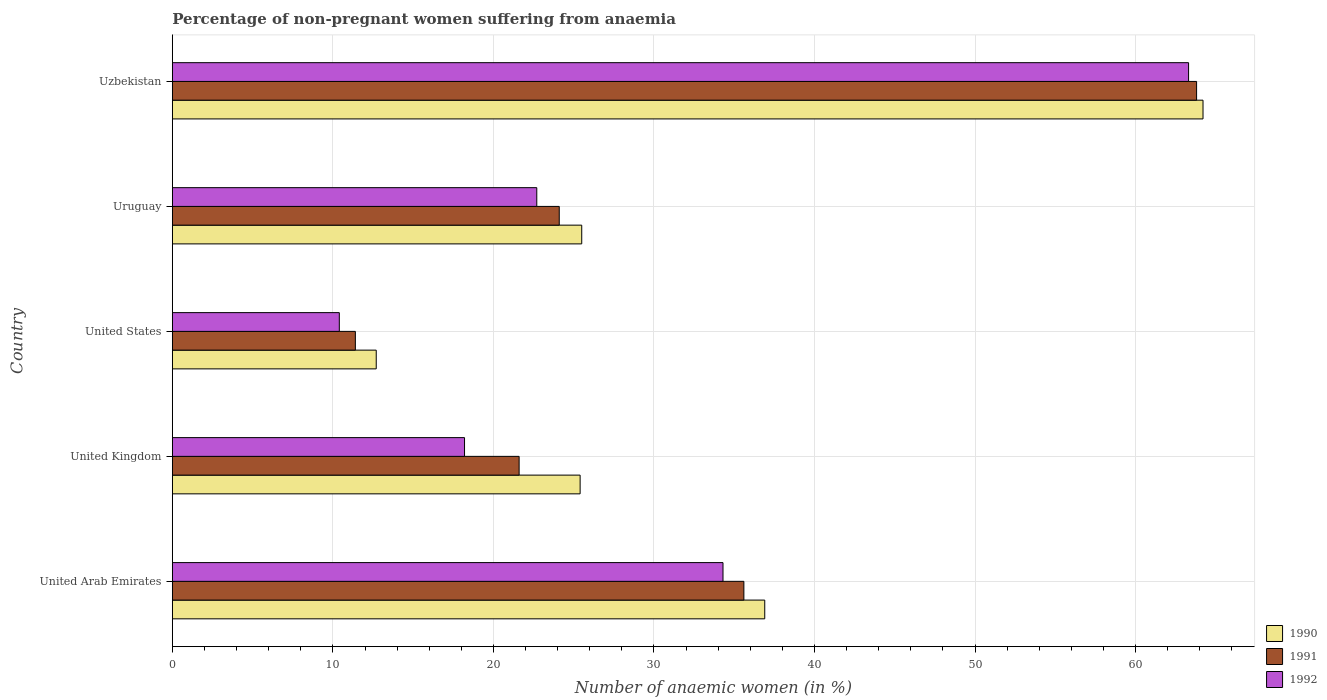How many different coloured bars are there?
Give a very brief answer. 3. Are the number of bars on each tick of the Y-axis equal?
Offer a very short reply. Yes. How many bars are there on the 5th tick from the bottom?
Provide a short and direct response. 3. What is the label of the 5th group of bars from the top?
Your response must be concise. United Arab Emirates. What is the percentage of non-pregnant women suffering from anaemia in 1991 in United Arab Emirates?
Offer a terse response. 35.6. Across all countries, what is the maximum percentage of non-pregnant women suffering from anaemia in 1991?
Your answer should be compact. 63.8. Across all countries, what is the minimum percentage of non-pregnant women suffering from anaemia in 1990?
Provide a short and direct response. 12.7. In which country was the percentage of non-pregnant women suffering from anaemia in 1990 maximum?
Provide a succinct answer. Uzbekistan. In which country was the percentage of non-pregnant women suffering from anaemia in 1990 minimum?
Provide a succinct answer. United States. What is the total percentage of non-pregnant women suffering from anaemia in 1991 in the graph?
Provide a succinct answer. 156.5. What is the difference between the percentage of non-pregnant women suffering from anaemia in 1992 in United Kingdom and that in United States?
Your answer should be very brief. 7.8. What is the difference between the percentage of non-pregnant women suffering from anaemia in 1990 in United Kingdom and the percentage of non-pregnant women suffering from anaemia in 1991 in Uzbekistan?
Provide a short and direct response. -38.4. What is the average percentage of non-pregnant women suffering from anaemia in 1992 per country?
Offer a very short reply. 29.78. What is the difference between the percentage of non-pregnant women suffering from anaemia in 1991 and percentage of non-pregnant women suffering from anaemia in 1992 in Uruguay?
Ensure brevity in your answer.  1.4. What is the ratio of the percentage of non-pregnant women suffering from anaemia in 1992 in United Arab Emirates to that in Uzbekistan?
Offer a very short reply. 0.54. Is the percentage of non-pregnant women suffering from anaemia in 1990 in United Kingdom less than that in Uzbekistan?
Give a very brief answer. Yes. Is the difference between the percentage of non-pregnant women suffering from anaemia in 1991 in Uruguay and Uzbekistan greater than the difference between the percentage of non-pregnant women suffering from anaemia in 1992 in Uruguay and Uzbekistan?
Ensure brevity in your answer.  Yes. What is the difference between the highest and the second highest percentage of non-pregnant women suffering from anaemia in 1990?
Provide a succinct answer. 27.3. What is the difference between the highest and the lowest percentage of non-pregnant women suffering from anaemia in 1991?
Make the answer very short. 52.4. In how many countries, is the percentage of non-pregnant women suffering from anaemia in 1991 greater than the average percentage of non-pregnant women suffering from anaemia in 1991 taken over all countries?
Your answer should be compact. 2. Is the sum of the percentage of non-pregnant women suffering from anaemia in 1991 in United Kingdom and United States greater than the maximum percentage of non-pregnant women suffering from anaemia in 1992 across all countries?
Offer a very short reply. No. What does the 2nd bar from the bottom in United States represents?
Make the answer very short. 1991. Is it the case that in every country, the sum of the percentage of non-pregnant women suffering from anaemia in 1990 and percentage of non-pregnant women suffering from anaemia in 1991 is greater than the percentage of non-pregnant women suffering from anaemia in 1992?
Give a very brief answer. Yes. How many bars are there?
Your answer should be very brief. 15. Are all the bars in the graph horizontal?
Provide a short and direct response. Yes. How many countries are there in the graph?
Your response must be concise. 5. What is the difference between two consecutive major ticks on the X-axis?
Offer a very short reply. 10. Where does the legend appear in the graph?
Ensure brevity in your answer.  Bottom right. How are the legend labels stacked?
Offer a very short reply. Vertical. What is the title of the graph?
Make the answer very short. Percentage of non-pregnant women suffering from anaemia. Does "2002" appear as one of the legend labels in the graph?
Ensure brevity in your answer.  No. What is the label or title of the X-axis?
Your answer should be compact. Number of anaemic women (in %). What is the Number of anaemic women (in %) in 1990 in United Arab Emirates?
Offer a terse response. 36.9. What is the Number of anaemic women (in %) in 1991 in United Arab Emirates?
Your answer should be compact. 35.6. What is the Number of anaemic women (in %) in 1992 in United Arab Emirates?
Provide a succinct answer. 34.3. What is the Number of anaemic women (in %) in 1990 in United Kingdom?
Offer a terse response. 25.4. What is the Number of anaemic women (in %) of 1991 in United Kingdom?
Offer a very short reply. 21.6. What is the Number of anaemic women (in %) of 1990 in United States?
Your answer should be very brief. 12.7. What is the Number of anaemic women (in %) in 1991 in United States?
Provide a succinct answer. 11.4. What is the Number of anaemic women (in %) of 1992 in United States?
Your answer should be compact. 10.4. What is the Number of anaemic women (in %) of 1991 in Uruguay?
Ensure brevity in your answer.  24.1. What is the Number of anaemic women (in %) in 1992 in Uruguay?
Ensure brevity in your answer.  22.7. What is the Number of anaemic women (in %) of 1990 in Uzbekistan?
Keep it short and to the point. 64.2. What is the Number of anaemic women (in %) in 1991 in Uzbekistan?
Your answer should be very brief. 63.8. What is the Number of anaemic women (in %) of 1992 in Uzbekistan?
Keep it short and to the point. 63.3. Across all countries, what is the maximum Number of anaemic women (in %) in 1990?
Offer a terse response. 64.2. Across all countries, what is the maximum Number of anaemic women (in %) in 1991?
Your answer should be compact. 63.8. Across all countries, what is the maximum Number of anaemic women (in %) of 1992?
Give a very brief answer. 63.3. Across all countries, what is the minimum Number of anaemic women (in %) of 1990?
Offer a terse response. 12.7. Across all countries, what is the minimum Number of anaemic women (in %) of 1992?
Your response must be concise. 10.4. What is the total Number of anaemic women (in %) of 1990 in the graph?
Offer a very short reply. 164.7. What is the total Number of anaemic women (in %) of 1991 in the graph?
Provide a succinct answer. 156.5. What is the total Number of anaemic women (in %) of 1992 in the graph?
Provide a short and direct response. 148.9. What is the difference between the Number of anaemic women (in %) of 1991 in United Arab Emirates and that in United Kingdom?
Ensure brevity in your answer.  14. What is the difference between the Number of anaemic women (in %) in 1992 in United Arab Emirates and that in United Kingdom?
Ensure brevity in your answer.  16.1. What is the difference between the Number of anaemic women (in %) of 1990 in United Arab Emirates and that in United States?
Ensure brevity in your answer.  24.2. What is the difference between the Number of anaemic women (in %) of 1991 in United Arab Emirates and that in United States?
Give a very brief answer. 24.2. What is the difference between the Number of anaemic women (in %) of 1992 in United Arab Emirates and that in United States?
Your answer should be very brief. 23.9. What is the difference between the Number of anaemic women (in %) of 1991 in United Arab Emirates and that in Uruguay?
Your answer should be very brief. 11.5. What is the difference between the Number of anaemic women (in %) of 1992 in United Arab Emirates and that in Uruguay?
Ensure brevity in your answer.  11.6. What is the difference between the Number of anaemic women (in %) of 1990 in United Arab Emirates and that in Uzbekistan?
Offer a very short reply. -27.3. What is the difference between the Number of anaemic women (in %) in 1991 in United Arab Emirates and that in Uzbekistan?
Make the answer very short. -28.2. What is the difference between the Number of anaemic women (in %) in 1992 in United Arab Emirates and that in Uzbekistan?
Your response must be concise. -29. What is the difference between the Number of anaemic women (in %) of 1990 in United Kingdom and that in United States?
Your answer should be very brief. 12.7. What is the difference between the Number of anaemic women (in %) in 1990 in United Kingdom and that in Uruguay?
Provide a succinct answer. -0.1. What is the difference between the Number of anaemic women (in %) of 1991 in United Kingdom and that in Uruguay?
Provide a short and direct response. -2.5. What is the difference between the Number of anaemic women (in %) of 1992 in United Kingdom and that in Uruguay?
Offer a terse response. -4.5. What is the difference between the Number of anaemic women (in %) in 1990 in United Kingdom and that in Uzbekistan?
Ensure brevity in your answer.  -38.8. What is the difference between the Number of anaemic women (in %) of 1991 in United Kingdom and that in Uzbekistan?
Provide a short and direct response. -42.2. What is the difference between the Number of anaemic women (in %) in 1992 in United Kingdom and that in Uzbekistan?
Ensure brevity in your answer.  -45.1. What is the difference between the Number of anaemic women (in %) in 1991 in United States and that in Uruguay?
Make the answer very short. -12.7. What is the difference between the Number of anaemic women (in %) in 1992 in United States and that in Uruguay?
Offer a terse response. -12.3. What is the difference between the Number of anaemic women (in %) in 1990 in United States and that in Uzbekistan?
Make the answer very short. -51.5. What is the difference between the Number of anaemic women (in %) of 1991 in United States and that in Uzbekistan?
Ensure brevity in your answer.  -52.4. What is the difference between the Number of anaemic women (in %) in 1992 in United States and that in Uzbekistan?
Your answer should be very brief. -52.9. What is the difference between the Number of anaemic women (in %) of 1990 in Uruguay and that in Uzbekistan?
Your response must be concise. -38.7. What is the difference between the Number of anaemic women (in %) in 1991 in Uruguay and that in Uzbekistan?
Your answer should be very brief. -39.7. What is the difference between the Number of anaemic women (in %) of 1992 in Uruguay and that in Uzbekistan?
Your answer should be very brief. -40.6. What is the difference between the Number of anaemic women (in %) in 1990 in United Arab Emirates and the Number of anaemic women (in %) in 1992 in United Kingdom?
Offer a terse response. 18.7. What is the difference between the Number of anaemic women (in %) in 1991 in United Arab Emirates and the Number of anaemic women (in %) in 1992 in United Kingdom?
Your answer should be compact. 17.4. What is the difference between the Number of anaemic women (in %) in 1990 in United Arab Emirates and the Number of anaemic women (in %) in 1991 in United States?
Give a very brief answer. 25.5. What is the difference between the Number of anaemic women (in %) of 1990 in United Arab Emirates and the Number of anaemic women (in %) of 1992 in United States?
Ensure brevity in your answer.  26.5. What is the difference between the Number of anaemic women (in %) in 1991 in United Arab Emirates and the Number of anaemic women (in %) in 1992 in United States?
Make the answer very short. 25.2. What is the difference between the Number of anaemic women (in %) of 1990 in United Arab Emirates and the Number of anaemic women (in %) of 1992 in Uruguay?
Your response must be concise. 14.2. What is the difference between the Number of anaemic women (in %) in 1990 in United Arab Emirates and the Number of anaemic women (in %) in 1991 in Uzbekistan?
Your answer should be compact. -26.9. What is the difference between the Number of anaemic women (in %) in 1990 in United Arab Emirates and the Number of anaemic women (in %) in 1992 in Uzbekistan?
Keep it short and to the point. -26.4. What is the difference between the Number of anaemic women (in %) of 1991 in United Arab Emirates and the Number of anaemic women (in %) of 1992 in Uzbekistan?
Keep it short and to the point. -27.7. What is the difference between the Number of anaemic women (in %) of 1990 in United Kingdom and the Number of anaemic women (in %) of 1992 in United States?
Your response must be concise. 15. What is the difference between the Number of anaemic women (in %) of 1991 in United Kingdom and the Number of anaemic women (in %) of 1992 in United States?
Provide a succinct answer. 11.2. What is the difference between the Number of anaemic women (in %) of 1991 in United Kingdom and the Number of anaemic women (in %) of 1992 in Uruguay?
Your response must be concise. -1.1. What is the difference between the Number of anaemic women (in %) of 1990 in United Kingdom and the Number of anaemic women (in %) of 1991 in Uzbekistan?
Your answer should be very brief. -38.4. What is the difference between the Number of anaemic women (in %) in 1990 in United Kingdom and the Number of anaemic women (in %) in 1992 in Uzbekistan?
Offer a terse response. -37.9. What is the difference between the Number of anaemic women (in %) in 1991 in United Kingdom and the Number of anaemic women (in %) in 1992 in Uzbekistan?
Ensure brevity in your answer.  -41.7. What is the difference between the Number of anaemic women (in %) of 1990 in United States and the Number of anaemic women (in %) of 1991 in Uruguay?
Make the answer very short. -11.4. What is the difference between the Number of anaemic women (in %) in 1990 in United States and the Number of anaemic women (in %) in 1992 in Uruguay?
Ensure brevity in your answer.  -10. What is the difference between the Number of anaemic women (in %) of 1990 in United States and the Number of anaemic women (in %) of 1991 in Uzbekistan?
Offer a terse response. -51.1. What is the difference between the Number of anaemic women (in %) in 1990 in United States and the Number of anaemic women (in %) in 1992 in Uzbekistan?
Offer a terse response. -50.6. What is the difference between the Number of anaemic women (in %) in 1991 in United States and the Number of anaemic women (in %) in 1992 in Uzbekistan?
Offer a very short reply. -51.9. What is the difference between the Number of anaemic women (in %) of 1990 in Uruguay and the Number of anaemic women (in %) of 1991 in Uzbekistan?
Provide a short and direct response. -38.3. What is the difference between the Number of anaemic women (in %) of 1990 in Uruguay and the Number of anaemic women (in %) of 1992 in Uzbekistan?
Offer a very short reply. -37.8. What is the difference between the Number of anaemic women (in %) in 1991 in Uruguay and the Number of anaemic women (in %) in 1992 in Uzbekistan?
Make the answer very short. -39.2. What is the average Number of anaemic women (in %) of 1990 per country?
Your response must be concise. 32.94. What is the average Number of anaemic women (in %) of 1991 per country?
Offer a terse response. 31.3. What is the average Number of anaemic women (in %) in 1992 per country?
Your response must be concise. 29.78. What is the difference between the Number of anaemic women (in %) of 1990 and Number of anaemic women (in %) of 1991 in United Arab Emirates?
Offer a very short reply. 1.3. What is the difference between the Number of anaemic women (in %) of 1990 and Number of anaemic women (in %) of 1992 in United Arab Emirates?
Offer a very short reply. 2.6. What is the difference between the Number of anaemic women (in %) in 1991 and Number of anaemic women (in %) in 1992 in United Arab Emirates?
Offer a very short reply. 1.3. What is the difference between the Number of anaemic women (in %) in 1990 and Number of anaemic women (in %) in 1991 in United Kingdom?
Your response must be concise. 3.8. What is the difference between the Number of anaemic women (in %) in 1990 and Number of anaemic women (in %) in 1992 in United Kingdom?
Provide a succinct answer. 7.2. What is the difference between the Number of anaemic women (in %) of 1991 and Number of anaemic women (in %) of 1992 in United Kingdom?
Ensure brevity in your answer.  3.4. What is the difference between the Number of anaemic women (in %) in 1990 and Number of anaemic women (in %) in 1992 in United States?
Your answer should be very brief. 2.3. What is the difference between the Number of anaemic women (in %) in 1991 and Number of anaemic women (in %) in 1992 in United States?
Make the answer very short. 1. What is the difference between the Number of anaemic women (in %) of 1990 and Number of anaemic women (in %) of 1992 in Uruguay?
Offer a very short reply. 2.8. What is the difference between the Number of anaemic women (in %) of 1991 and Number of anaemic women (in %) of 1992 in Uruguay?
Offer a terse response. 1.4. What is the difference between the Number of anaemic women (in %) of 1990 and Number of anaemic women (in %) of 1991 in Uzbekistan?
Your answer should be very brief. 0.4. What is the ratio of the Number of anaemic women (in %) of 1990 in United Arab Emirates to that in United Kingdom?
Offer a terse response. 1.45. What is the ratio of the Number of anaemic women (in %) of 1991 in United Arab Emirates to that in United Kingdom?
Offer a terse response. 1.65. What is the ratio of the Number of anaemic women (in %) in 1992 in United Arab Emirates to that in United Kingdom?
Ensure brevity in your answer.  1.88. What is the ratio of the Number of anaemic women (in %) of 1990 in United Arab Emirates to that in United States?
Your answer should be compact. 2.91. What is the ratio of the Number of anaemic women (in %) in 1991 in United Arab Emirates to that in United States?
Provide a short and direct response. 3.12. What is the ratio of the Number of anaemic women (in %) of 1992 in United Arab Emirates to that in United States?
Keep it short and to the point. 3.3. What is the ratio of the Number of anaemic women (in %) of 1990 in United Arab Emirates to that in Uruguay?
Give a very brief answer. 1.45. What is the ratio of the Number of anaemic women (in %) of 1991 in United Arab Emirates to that in Uruguay?
Your answer should be compact. 1.48. What is the ratio of the Number of anaemic women (in %) of 1992 in United Arab Emirates to that in Uruguay?
Your answer should be compact. 1.51. What is the ratio of the Number of anaemic women (in %) of 1990 in United Arab Emirates to that in Uzbekistan?
Make the answer very short. 0.57. What is the ratio of the Number of anaemic women (in %) in 1991 in United Arab Emirates to that in Uzbekistan?
Offer a very short reply. 0.56. What is the ratio of the Number of anaemic women (in %) of 1992 in United Arab Emirates to that in Uzbekistan?
Provide a short and direct response. 0.54. What is the ratio of the Number of anaemic women (in %) in 1990 in United Kingdom to that in United States?
Your answer should be very brief. 2. What is the ratio of the Number of anaemic women (in %) of 1991 in United Kingdom to that in United States?
Ensure brevity in your answer.  1.89. What is the ratio of the Number of anaemic women (in %) of 1990 in United Kingdom to that in Uruguay?
Offer a very short reply. 1. What is the ratio of the Number of anaemic women (in %) of 1991 in United Kingdom to that in Uruguay?
Your response must be concise. 0.9. What is the ratio of the Number of anaemic women (in %) of 1992 in United Kingdom to that in Uruguay?
Provide a succinct answer. 0.8. What is the ratio of the Number of anaemic women (in %) of 1990 in United Kingdom to that in Uzbekistan?
Keep it short and to the point. 0.4. What is the ratio of the Number of anaemic women (in %) in 1991 in United Kingdom to that in Uzbekistan?
Your answer should be compact. 0.34. What is the ratio of the Number of anaemic women (in %) of 1992 in United Kingdom to that in Uzbekistan?
Your answer should be very brief. 0.29. What is the ratio of the Number of anaemic women (in %) of 1990 in United States to that in Uruguay?
Give a very brief answer. 0.5. What is the ratio of the Number of anaemic women (in %) in 1991 in United States to that in Uruguay?
Offer a terse response. 0.47. What is the ratio of the Number of anaemic women (in %) in 1992 in United States to that in Uruguay?
Ensure brevity in your answer.  0.46. What is the ratio of the Number of anaemic women (in %) of 1990 in United States to that in Uzbekistan?
Give a very brief answer. 0.2. What is the ratio of the Number of anaemic women (in %) of 1991 in United States to that in Uzbekistan?
Make the answer very short. 0.18. What is the ratio of the Number of anaemic women (in %) in 1992 in United States to that in Uzbekistan?
Keep it short and to the point. 0.16. What is the ratio of the Number of anaemic women (in %) of 1990 in Uruguay to that in Uzbekistan?
Your response must be concise. 0.4. What is the ratio of the Number of anaemic women (in %) of 1991 in Uruguay to that in Uzbekistan?
Provide a succinct answer. 0.38. What is the ratio of the Number of anaemic women (in %) of 1992 in Uruguay to that in Uzbekistan?
Offer a terse response. 0.36. What is the difference between the highest and the second highest Number of anaemic women (in %) in 1990?
Provide a succinct answer. 27.3. What is the difference between the highest and the second highest Number of anaemic women (in %) of 1991?
Keep it short and to the point. 28.2. What is the difference between the highest and the second highest Number of anaemic women (in %) of 1992?
Your response must be concise. 29. What is the difference between the highest and the lowest Number of anaemic women (in %) of 1990?
Offer a very short reply. 51.5. What is the difference between the highest and the lowest Number of anaemic women (in %) of 1991?
Offer a terse response. 52.4. What is the difference between the highest and the lowest Number of anaemic women (in %) in 1992?
Keep it short and to the point. 52.9. 